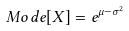Convert formula to latex. <formula><loc_0><loc_0><loc_500><loc_500>M o d e [ X ] = e ^ { \mu - \sigma ^ { 2 } }</formula> 